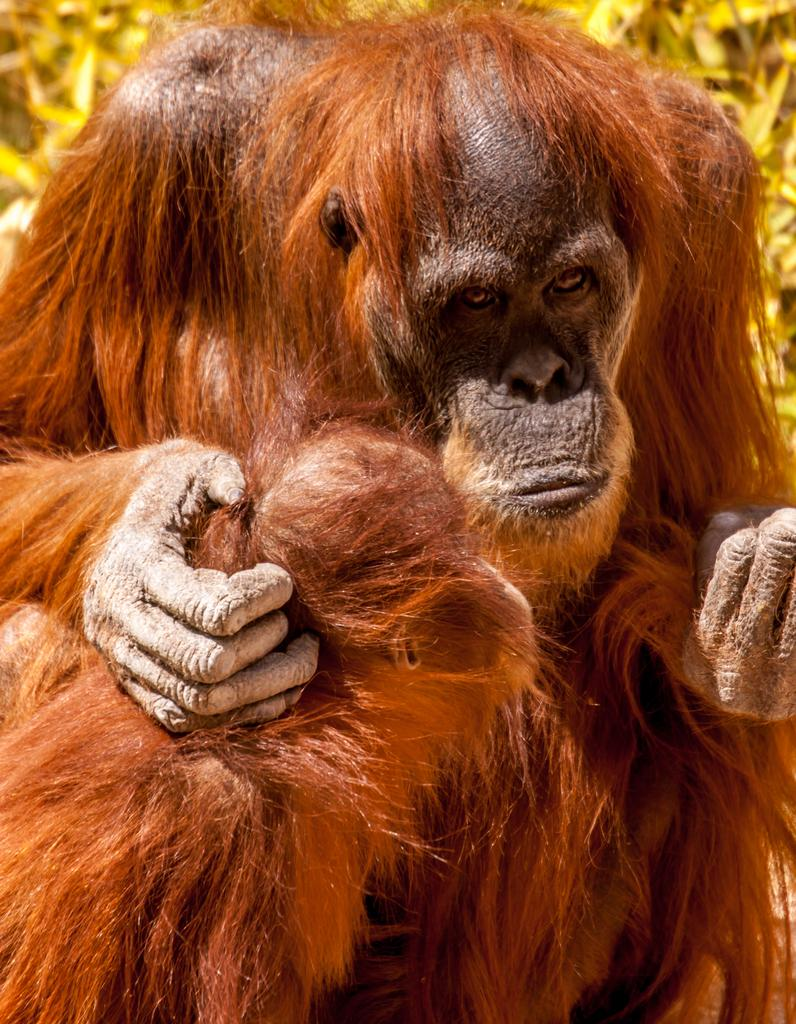How many chimpanzees are in the image? There are two chimpanzees in the image. What can be seen in the background of the image? There are plants in the background of the image. What rule does the farmer enforce on the chimpanzees in the image? There is no farmer present in the image, and therefore no rules can be enforced on the chimpanzees. How many times do the chimpanzees bite each other in the image? There is no indication of any biting behavior between the chimpanzees in the image. 